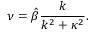<formula> <loc_0><loc_0><loc_500><loc_500>\nu = \hat { \beta } \frac { k } { k ^ { 2 } + \kappa ^ { 2 } } .</formula> 